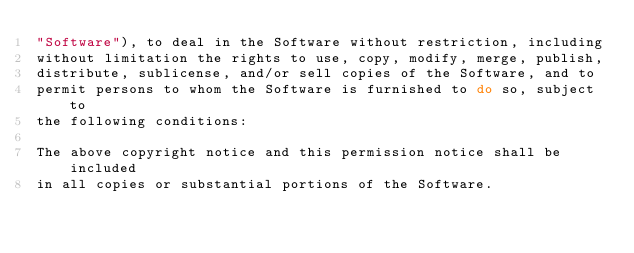Convert code to text. <code><loc_0><loc_0><loc_500><loc_500><_C_>"Software"), to deal in the Software without restriction, including
without limitation the rights to use, copy, modify, merge, publish,
distribute, sublicense, and/or sell copies of the Software, and to
permit persons to whom the Software is furnished to do so, subject to
the following conditions:

The above copyright notice and this permission notice shall be included
in all copies or substantial portions of the Software.
</code> 